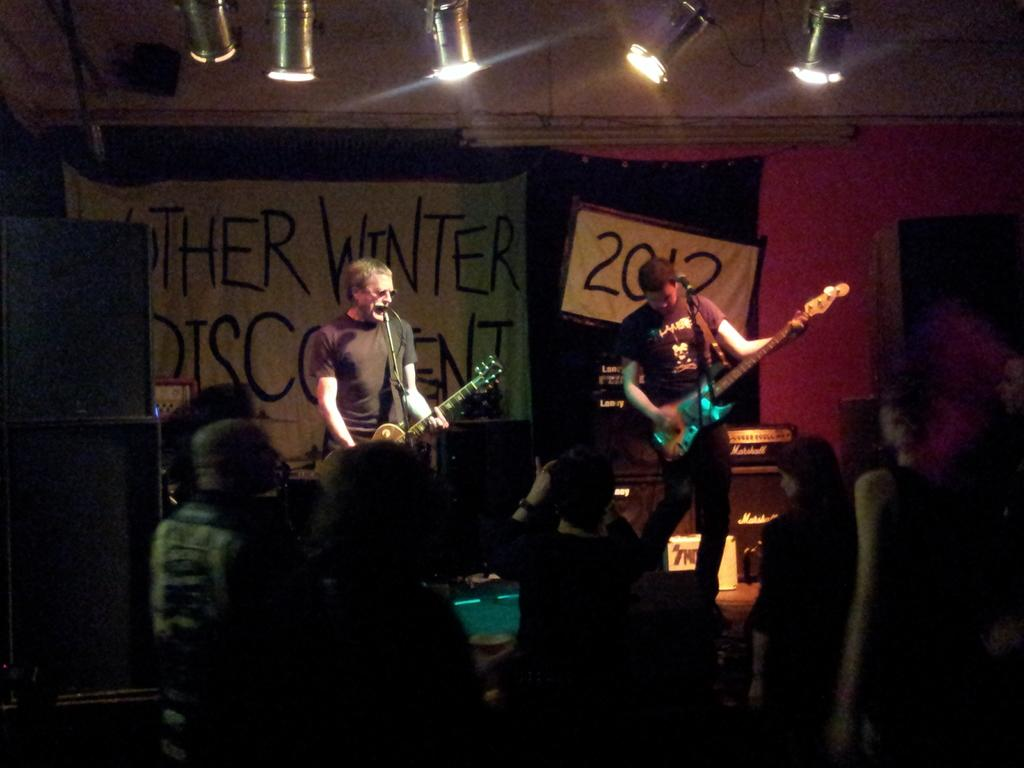What are the people in the image doing? The people in the image are playing guitar. What equipment is being used by the guitar players? The guitar players have microphones in front of them. How are the people in the image reacting to the music? There is a group of people enjoying the music. What can be seen in the image that provides illumination? There are lights visible in the image. How many lizards can be seen crawling on the furniture in the image? There are no lizards or furniture present in the image. What type of pin is being used to hold the sheet music on the guitar? There is no pin visible in the image, and it is not mentioned that sheet music is being used. 